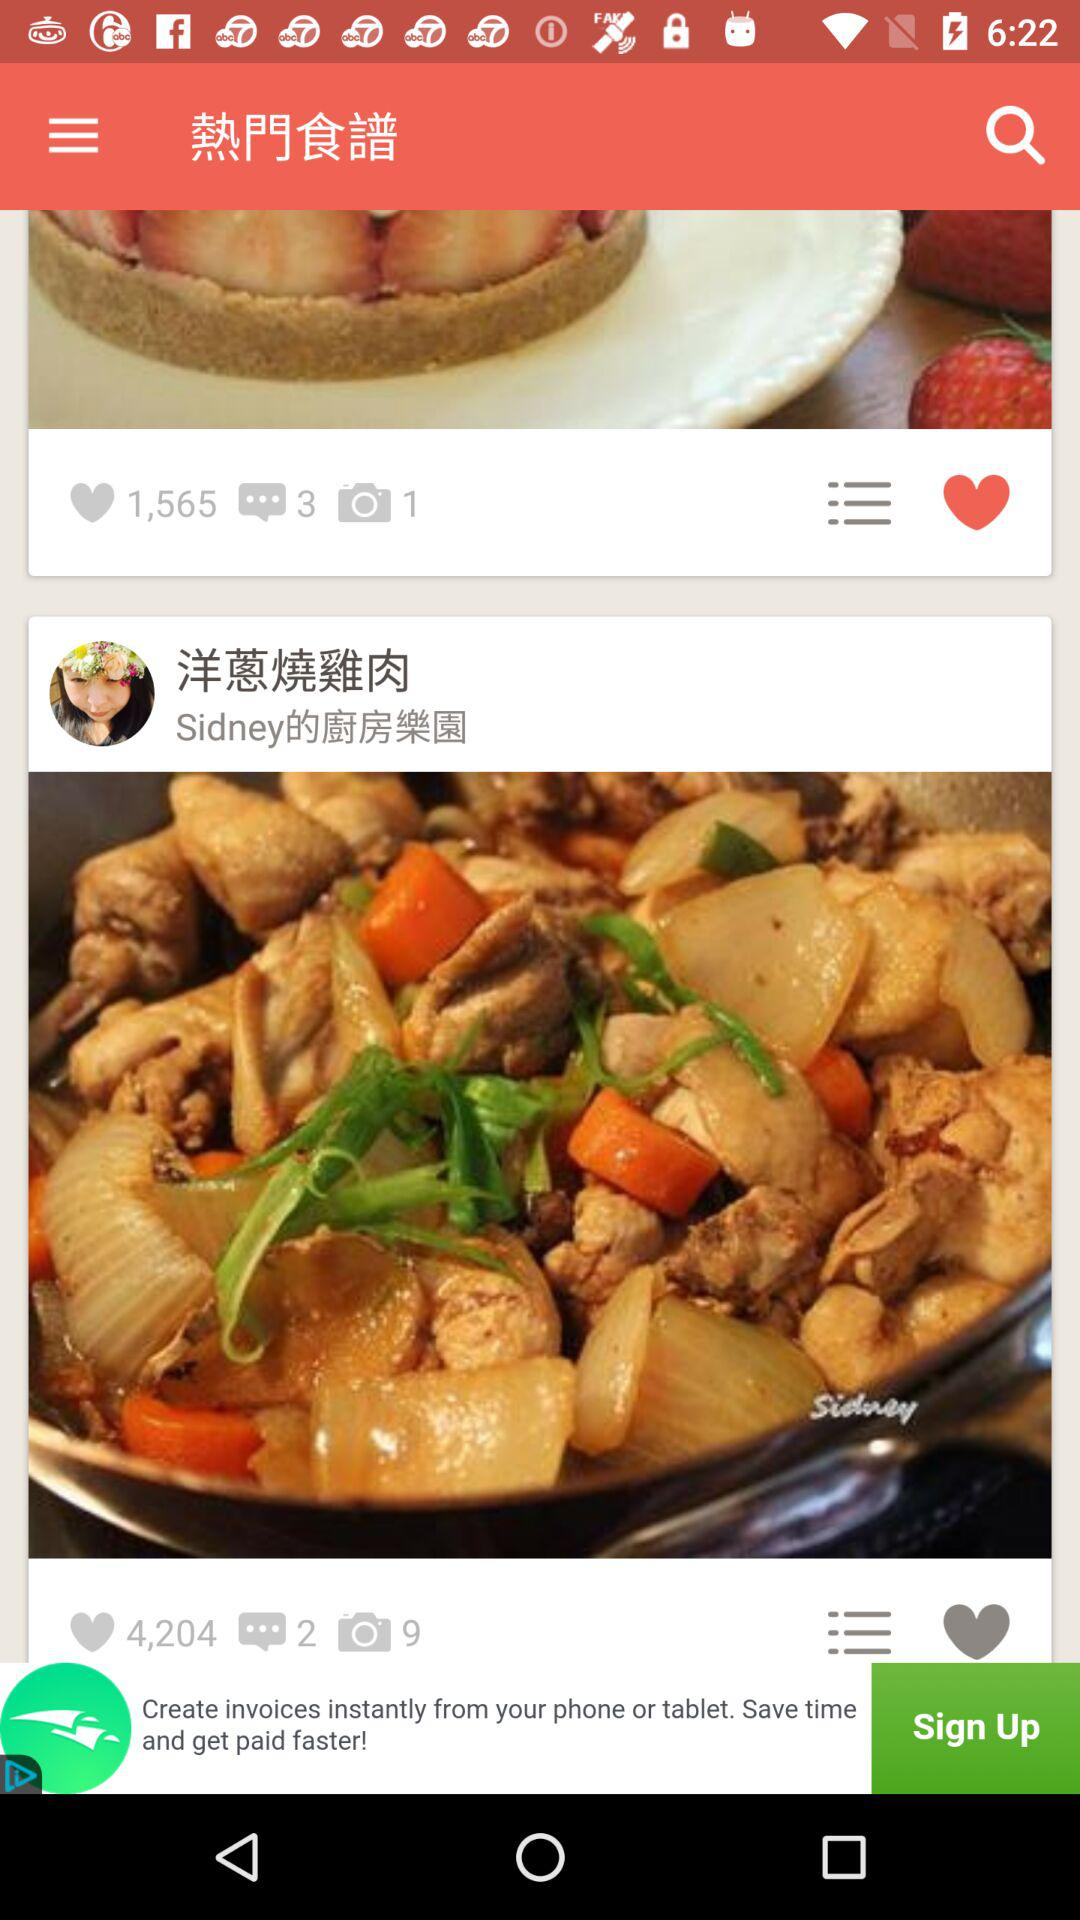How many more hearts does the second recipe have than the first?
Answer the question using a single word or phrase. 2639 